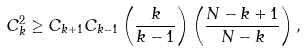Convert formula to latex. <formula><loc_0><loc_0><loc_500><loc_500>C _ { k } ^ { 2 } \geq C _ { k + 1 } C _ { k - 1 } \left ( \frac { k } { k - 1 } \right ) \left ( \frac { N - k + 1 } { N - k } \right ) ,</formula> 